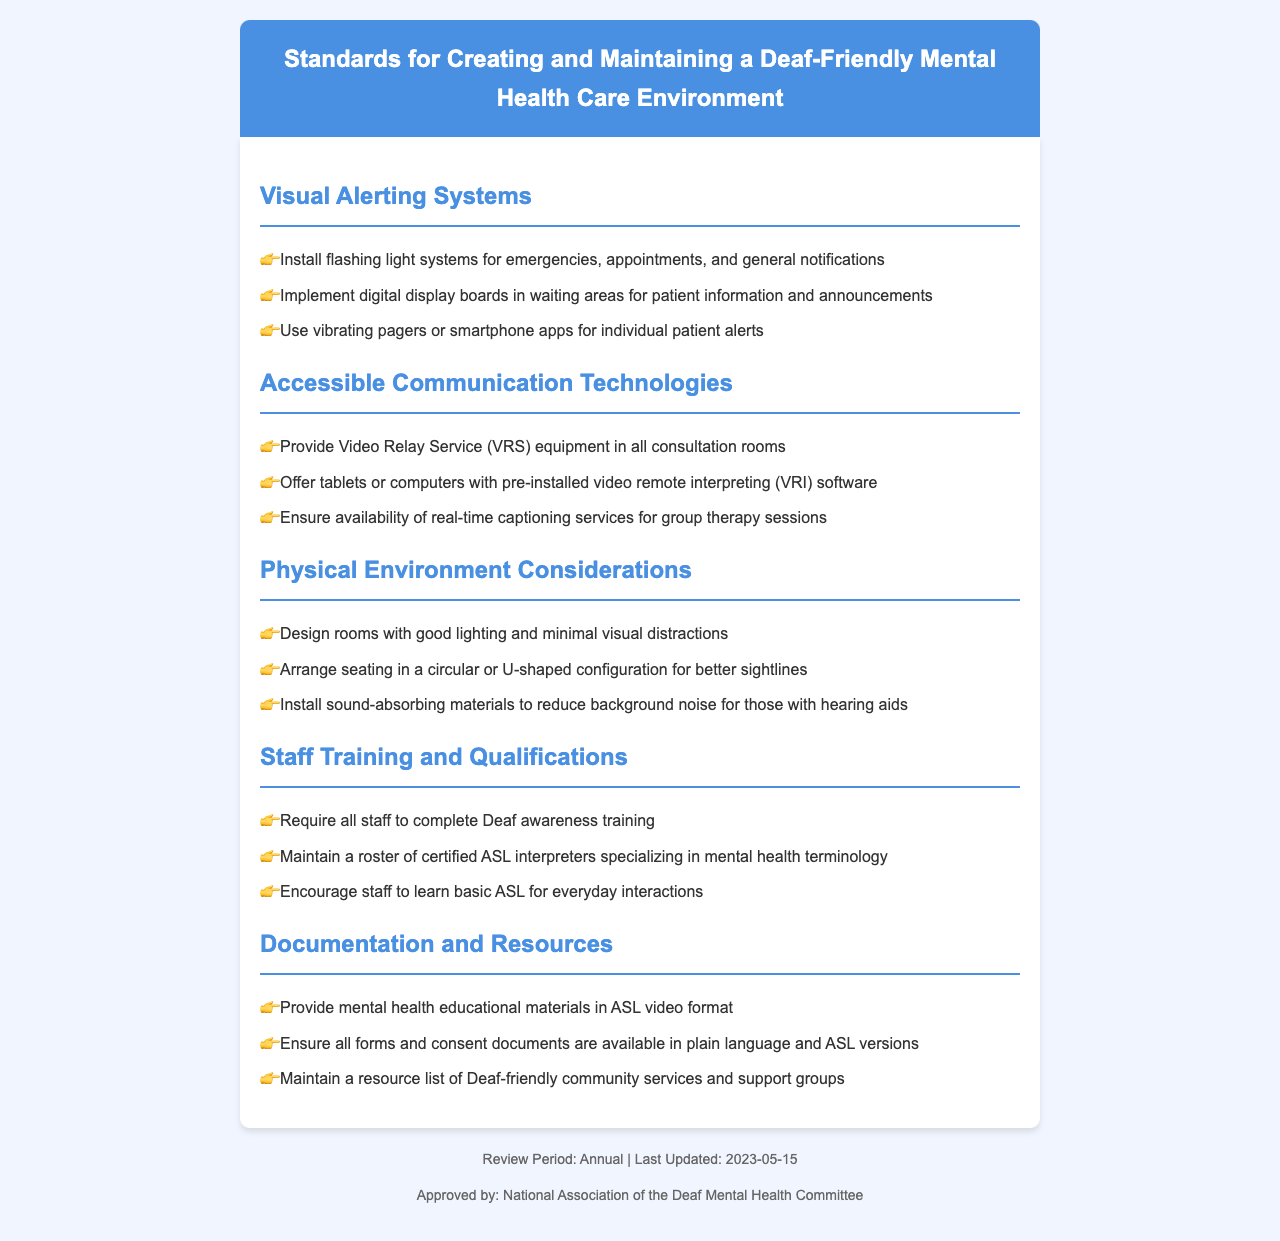what is the title of the document? The title of the document is provided in the header section of the document.
Answer: Standards for Creating and Maintaining a Deaf-Friendly Mental Health Care Environment how often should the document be reviewed? The review period is mentioned in the footer of the document.
Answer: Annual what type of alerting system should be installed for emergencies? The specific type of alerting system is outlined in the Visual Alerting Systems section.
Answer: Flashing light systems what services should be provided in consultation rooms? The services that should be available are listed under Accessible Communication Technologies.
Answer: Video Relay Service (VRS) equipment how should seating be arranged for better sightlines? The preferred seating arrangement is described in the Physical Environment Considerations section.
Answer: Circular or U-shaped what training is required for all staff? The requirement for staff training is detailed in the Staff Training and Qualifications section.
Answer: Deaf awareness training what format should mental health educational materials be provided in? The format for educational materials is specified under Documentation and Resources.
Answer: ASL video format how many items are listed under Visual Alerting Systems? The number of items can be counted from the list provided in that section.
Answer: Three what is maintained to support staff qualifications? The resources related to staff qualifications are described in the Staff Training and Qualifications section.
Answer: Roster of certified ASL interpreters 